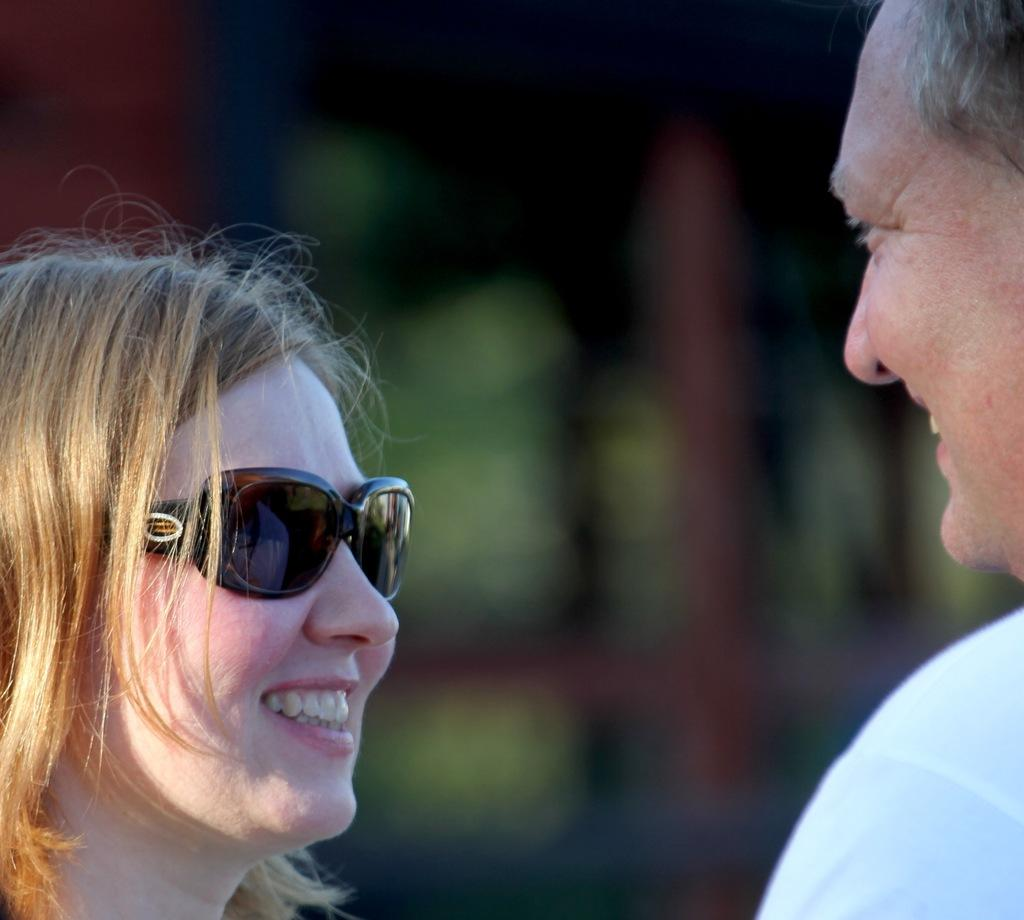Who are the people in the foreground of the image? There is a man and a woman in the foreground of the image. Can you describe the background of the image? The background of the image is blurred. What impulse did the man feel when he saw the snow in the image? There is no mention of snow in the image, and therefore no impulse related to snow can be observed. 